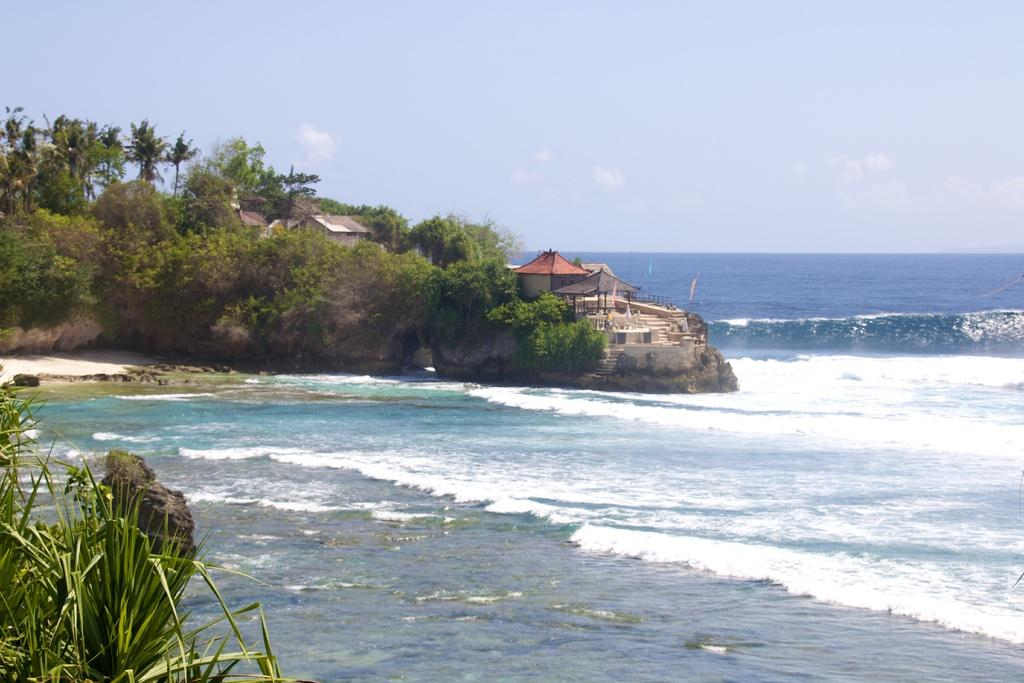What type of natural environment is depicted in the image? There is a beach in the image. Are there any structures located near the beach? Yes, there are houses beside the beach in the image. What type of vegetation can be seen in the image? There are trees in the image. What type of chair is visible on the beach in the image? There is no chair visible on the beach in the image. What kind of stone can be seen being flexed by a muscle in the image? There is no stone or muscle present in the image. 